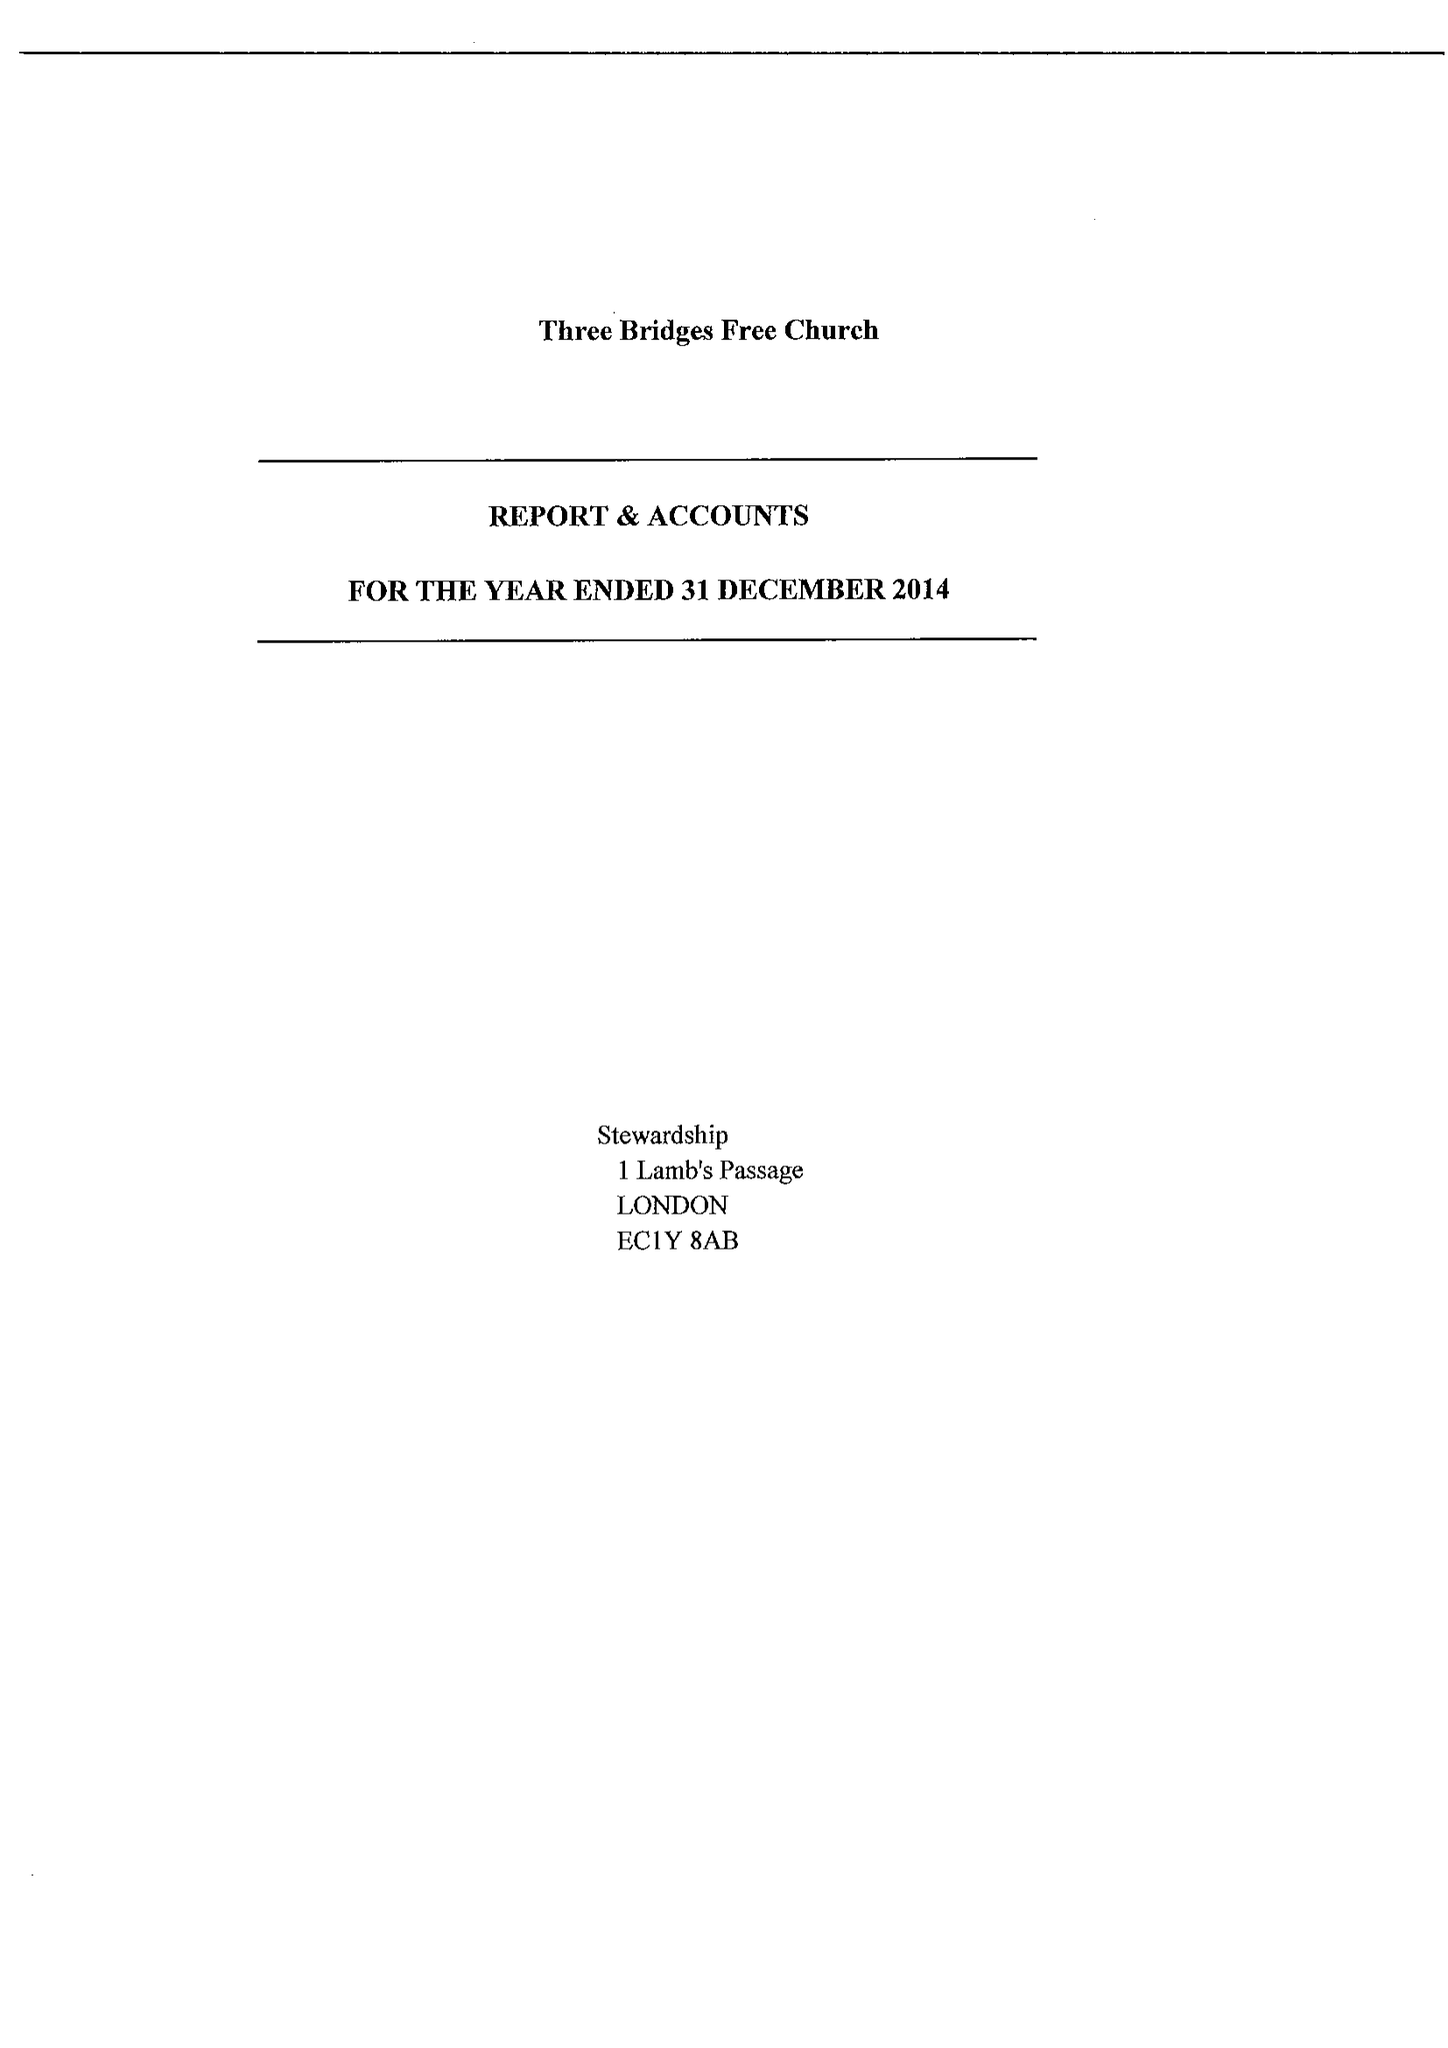What is the value for the charity_number?
Answer the question using a single word or phrase. 1074518 